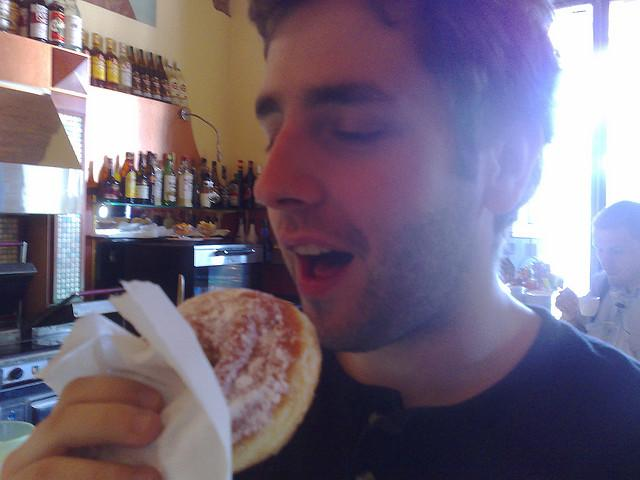How was the item prepared that is about to be bitten?

Choices:
A) deep fried
B) broiled
C) its raw
D) baked deep fried 